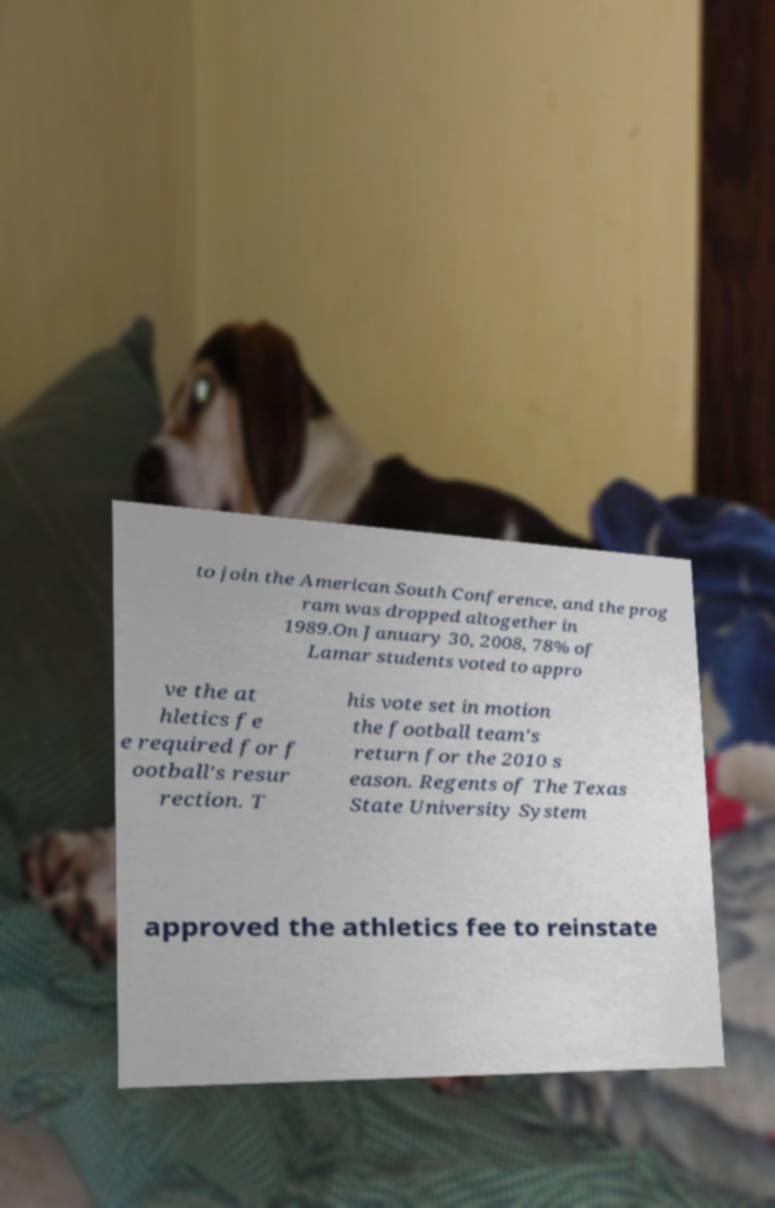Please identify and transcribe the text found in this image. to join the American South Conference, and the prog ram was dropped altogether in 1989.On January 30, 2008, 78% of Lamar students voted to appro ve the at hletics fe e required for f ootball's resur rection. T his vote set in motion the football team's return for the 2010 s eason. Regents of The Texas State University System approved the athletics fee to reinstate 